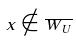Convert formula to latex. <formula><loc_0><loc_0><loc_500><loc_500>x \notin \overline { W _ { U } }</formula> 